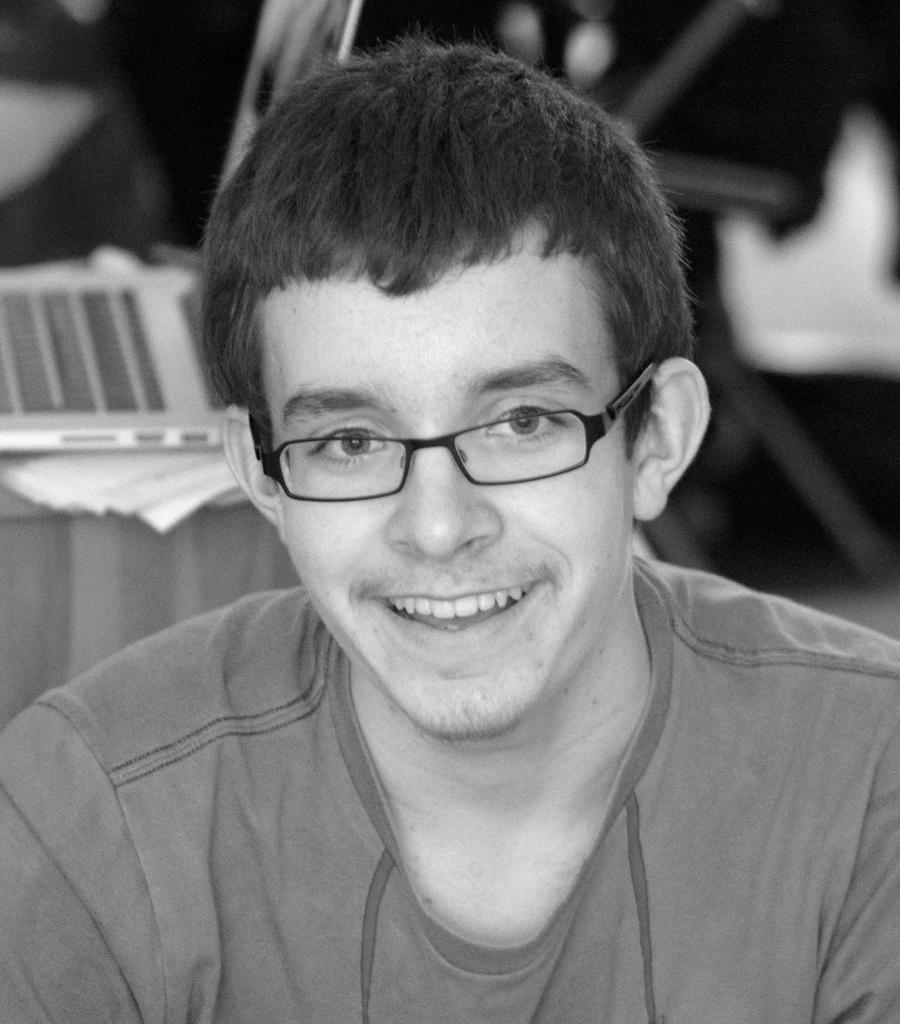What can be seen in the picture? There is a person in the picture. Can you describe the person's appearance? The person is wearing spectacles. What is visible behind the person? There are objects visible behind the person. What type of sail can be seen on the person's clothing in the image? There is no sail visible on the person's clothing in the image. Is the person in jail in the image? There is no indication in the image that the person is in jail. 